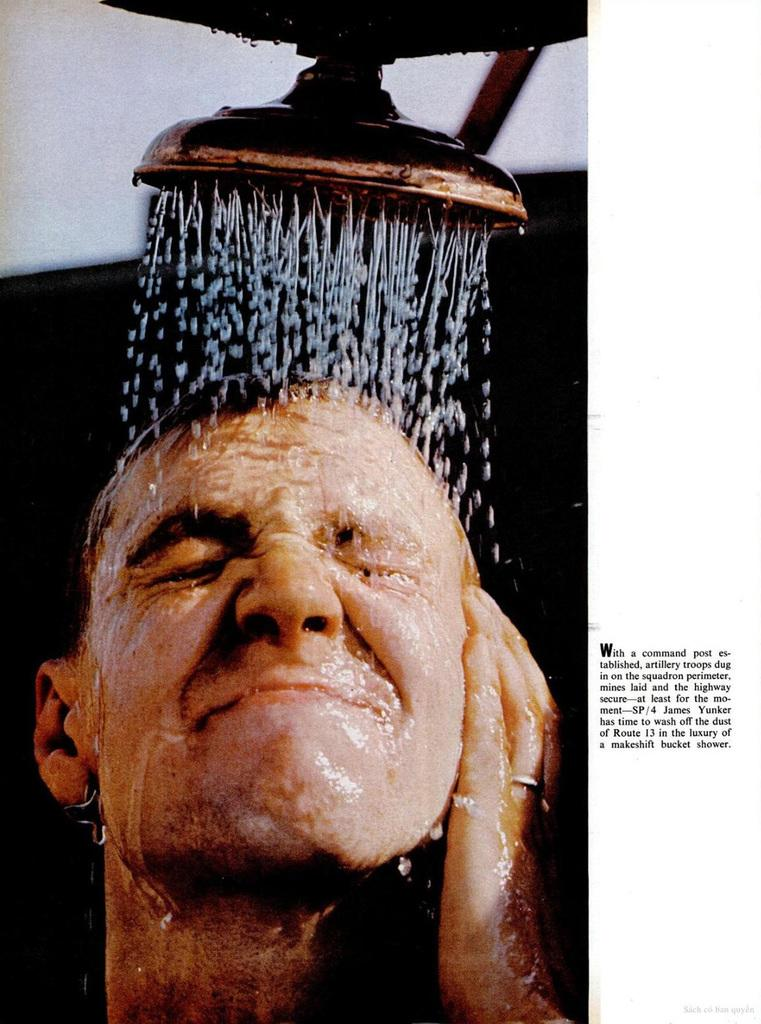What is the main subject of the image? There is a person in the image. What activity is the person engaged in? The image shows a person in a shower. What is the color scheme of the image? The background of the image is black and white. How many babies are visible in the image? There are no babies present in the image. Can you describe the wound on the person's body in the image? There is no wound visible on the person's body in the image. 